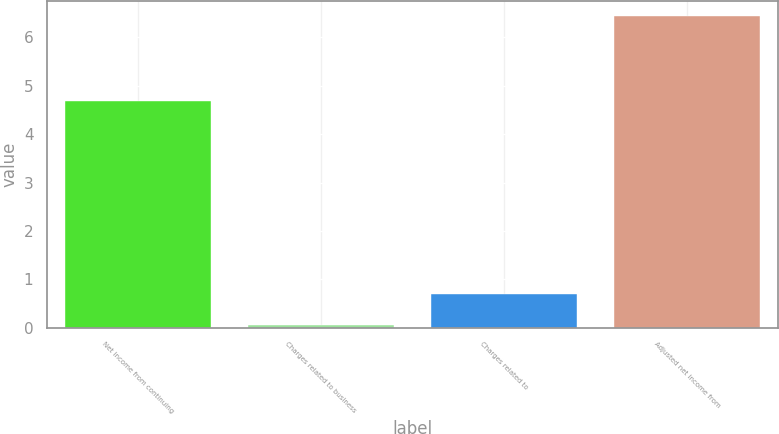Convert chart. <chart><loc_0><loc_0><loc_500><loc_500><bar_chart><fcel>Net income from continuing<fcel>Charges related to business<fcel>Charges related to<fcel>Adjusted net income from<nl><fcel>4.69<fcel>0.05<fcel>0.69<fcel>6.44<nl></chart> 